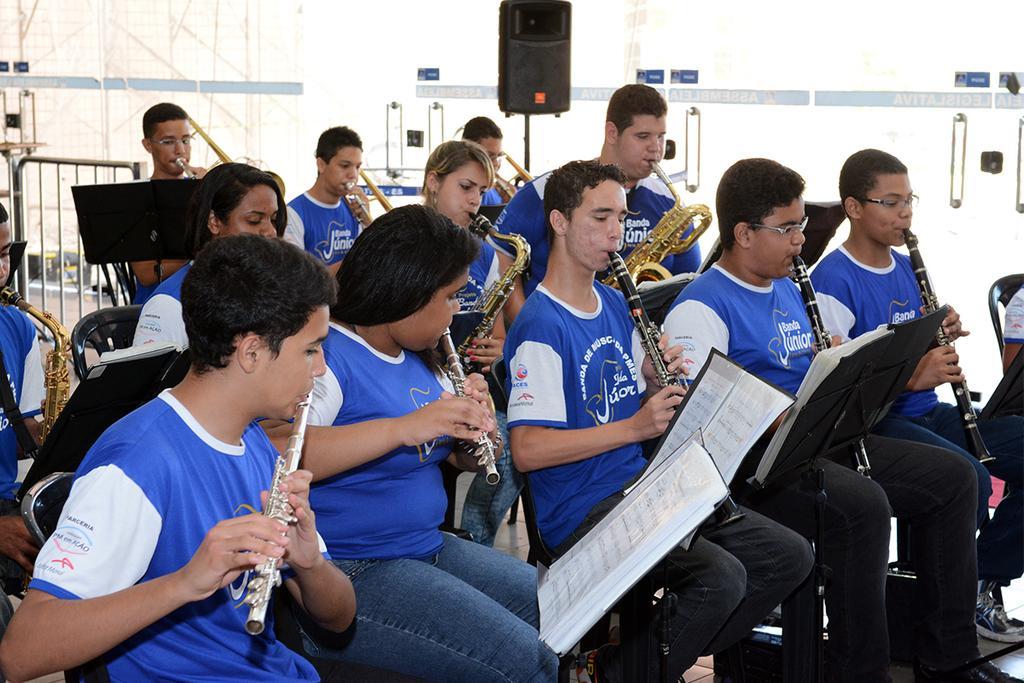Please provide a concise description of this image. In this image I can see a group of people are sitting on the chairs and playing musical instruments and holding books in their hand. In the background I can see a fence, road and a speaker. This image is taken during a day. 